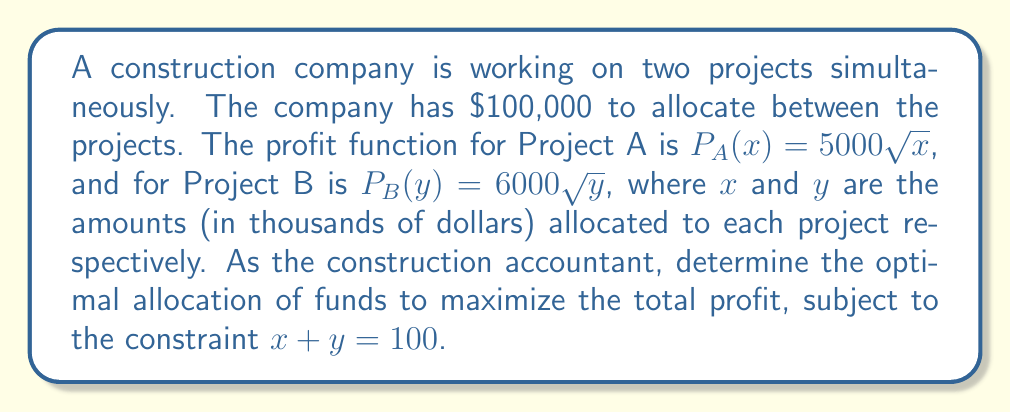Solve this math problem. To solve this optimization problem, we'll use the method of Lagrange multipliers:

1) Define the objective function:
   $$f(x,y) = 5000\sqrt{x} + 6000\sqrt{y}$$

2) Define the constraint:
   $$g(x,y) = x + y - 100 = 0$$

3) Form the Lagrangian:
   $$L(x,y,\lambda) = 5000\sqrt{x} + 6000\sqrt{y} - \lambda(x + y - 100)$$

4) Take partial derivatives and set them to zero:
   $$\frac{\partial L}{\partial x} = \frac{2500}{\sqrt{x}} - \lambda = 0$$
   $$\frac{\partial L}{\partial y} = \frac{3000}{\sqrt{y}} - \lambda = 0$$
   $$\frac{\partial L}{\partial \lambda} = x + y - 100 = 0$$

5) From the first two equations:
   $$\frac{2500}{\sqrt{x}} = \frac{3000}{\sqrt{y}}$$

6) Cross-multiply:
   $$2500\sqrt{y} = 3000\sqrt{x}$$
   $$\frac{25^2}{36^2} = \frac{x}{y}$$
   $$\frac{625}{1296} = \frac{x}{y}$$

7) Let $y = 100 - x$ (from the constraint):
   $$\frac{625}{1296} = \frac{x}{100-x}$$

8) Solve for x:
   $$625(100-x) = 1296x$$
   $$62500 - 625x = 1296x$$
   $$62500 = 1921x$$
   $$x \approx 32.53$$

9) Therefore, $y \approx 67.47$

10) The maximum profit is:
    $$5000\sqrt{32.53} + 6000\sqrt{67.47} \approx 77,460$$
Answer: $x \approx 32,530, y \approx 67,470; \text{Maximum profit} \approx \$77,460$ 